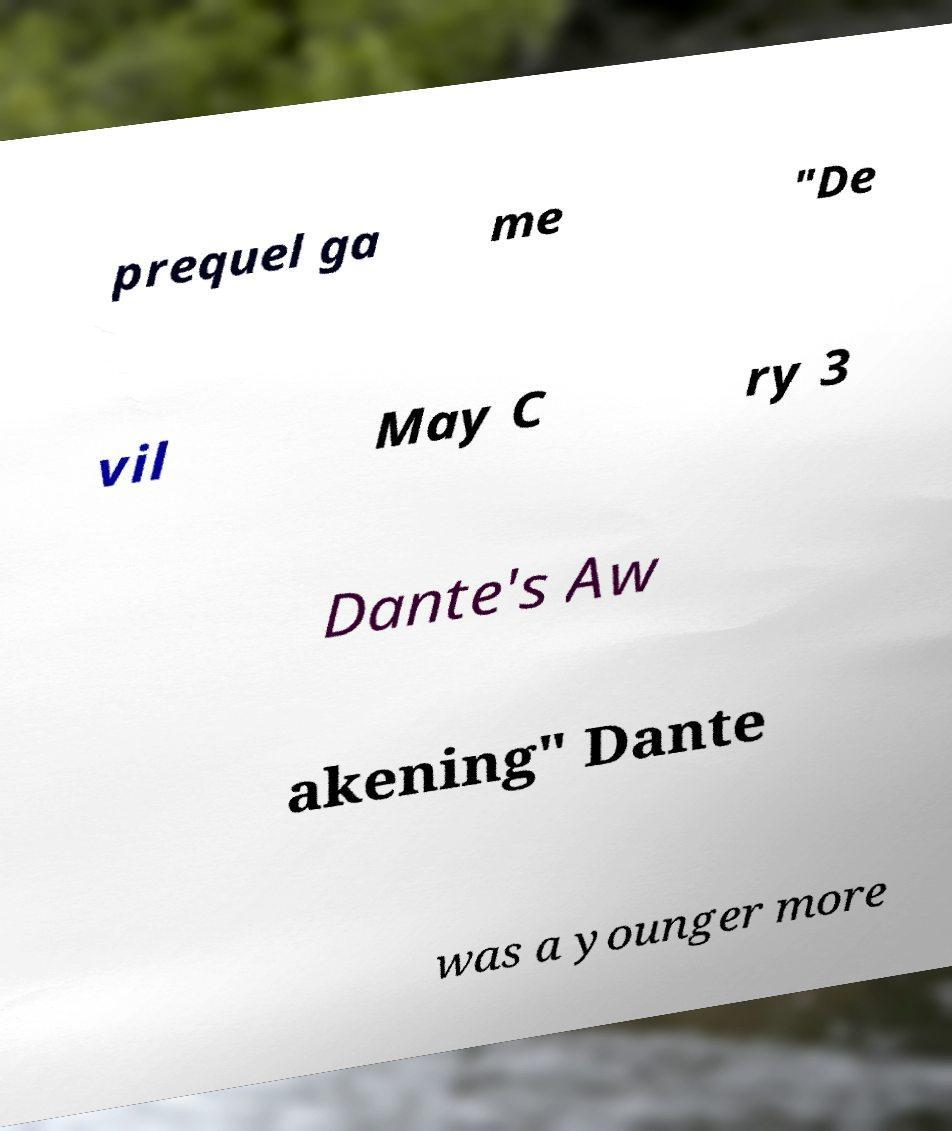Please read and relay the text visible in this image. What does it say? prequel ga me "De vil May C ry 3 Dante's Aw akening" Dante was a younger more 